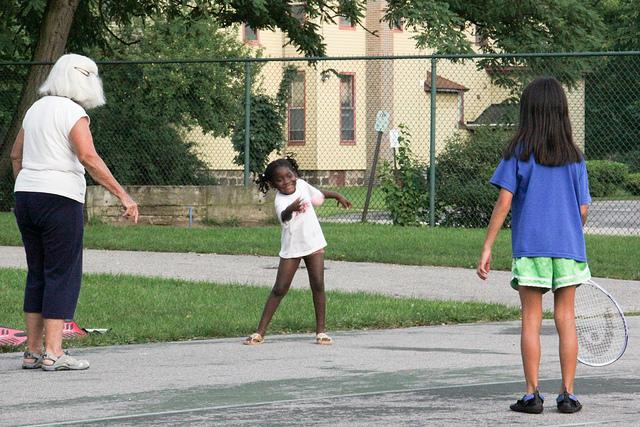What type of sporting area are girls most likely playing on?

Choices:
A) tennis court
B) soccer field
C) basketball stadium
D) baseball diamond tennis court 